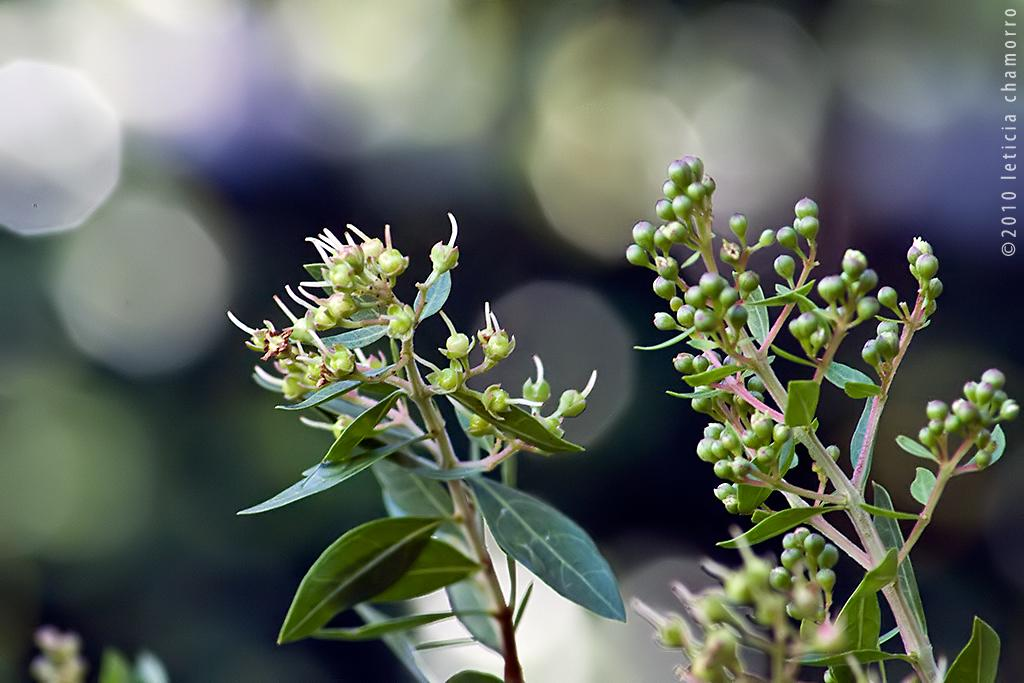What is located in the middle of the image? There are plants in the middle of the image. What stage of growth are the plants in? There are buds in the image, indicating that they are in the early stages of growth. What else can be seen on the plants? There are leaves in the image. What is present on the right side of the image? There is text on the right side of the image. What grade of coffee is being served in the cup in the image? There is no cup or coffee present in the image; it features plants with buds and leaves, along with text on the right side. 